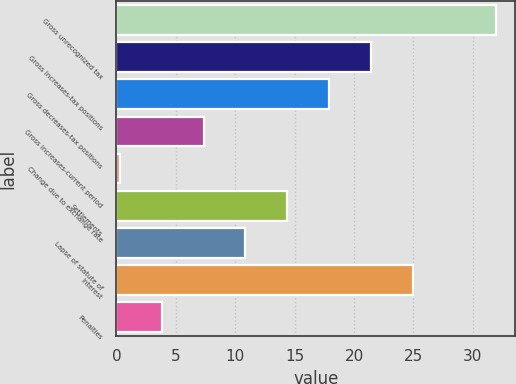<chart> <loc_0><loc_0><loc_500><loc_500><bar_chart><fcel>Gross unrecognized tax<fcel>Gross increases-tax positions<fcel>Gross decreases-tax positions<fcel>Gross increases-current period<fcel>Change due to exchange rate<fcel>Settlements<fcel>Lapse of statute of<fcel>Interest<fcel>Penalties<nl><fcel>31.98<fcel>21.42<fcel>17.9<fcel>7.34<fcel>0.3<fcel>14.38<fcel>10.86<fcel>24.94<fcel>3.82<nl></chart> 